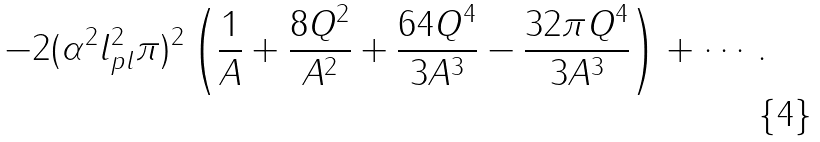<formula> <loc_0><loc_0><loc_500><loc_500>- 2 ( \alpha ^ { 2 } l _ { p l } ^ { 2 } \pi ) ^ { 2 } \left ( { \frac { 1 } { A } + \frac { 8 Q ^ { 2 } } { A ^ { 2 } } + \frac { 6 4 Q ^ { 4 } } { 3 A ^ { 3 } } - \frac { 3 2 \pi Q ^ { 4 } } { 3 A ^ { 3 } } } \right ) + \cdots .</formula> 